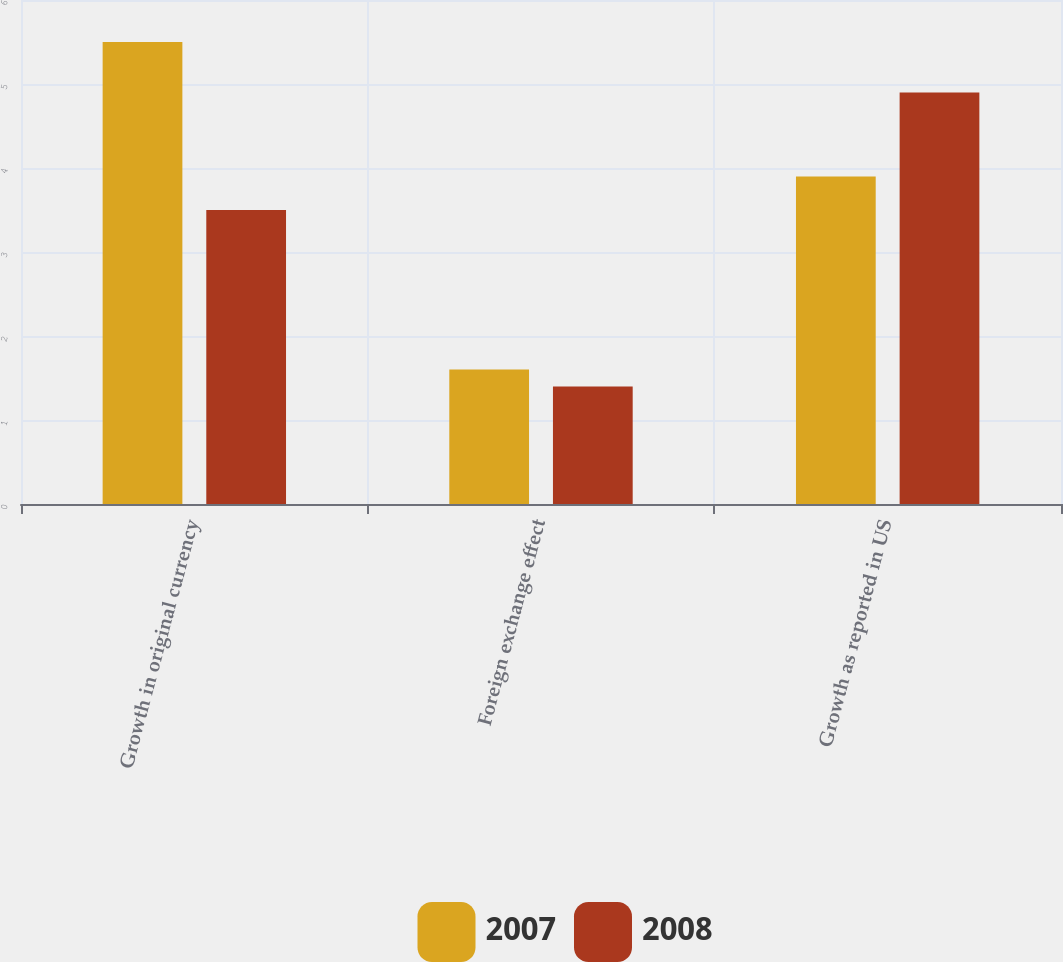<chart> <loc_0><loc_0><loc_500><loc_500><stacked_bar_chart><ecel><fcel>Growth in original currency<fcel>Foreign exchange effect<fcel>Growth as reported in US<nl><fcel>2007<fcel>5.5<fcel>1.6<fcel>3.9<nl><fcel>2008<fcel>3.5<fcel>1.4<fcel>4.9<nl></chart> 